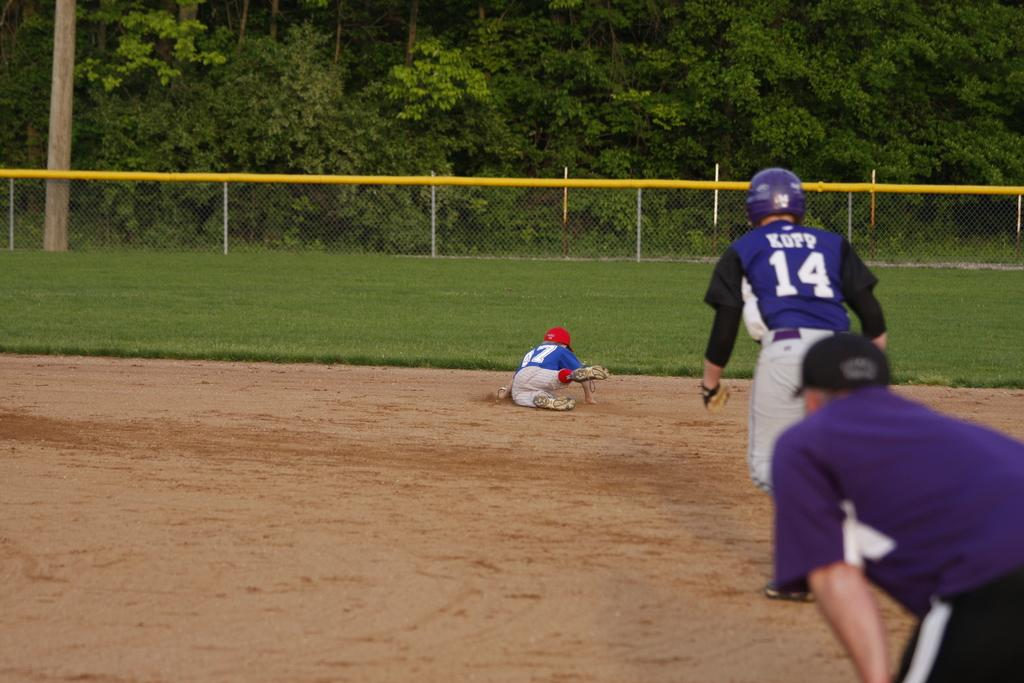Provide a one-sentence caption for the provided image. Baseball hitter no. 14 looks on as the defender dives for the ball. 